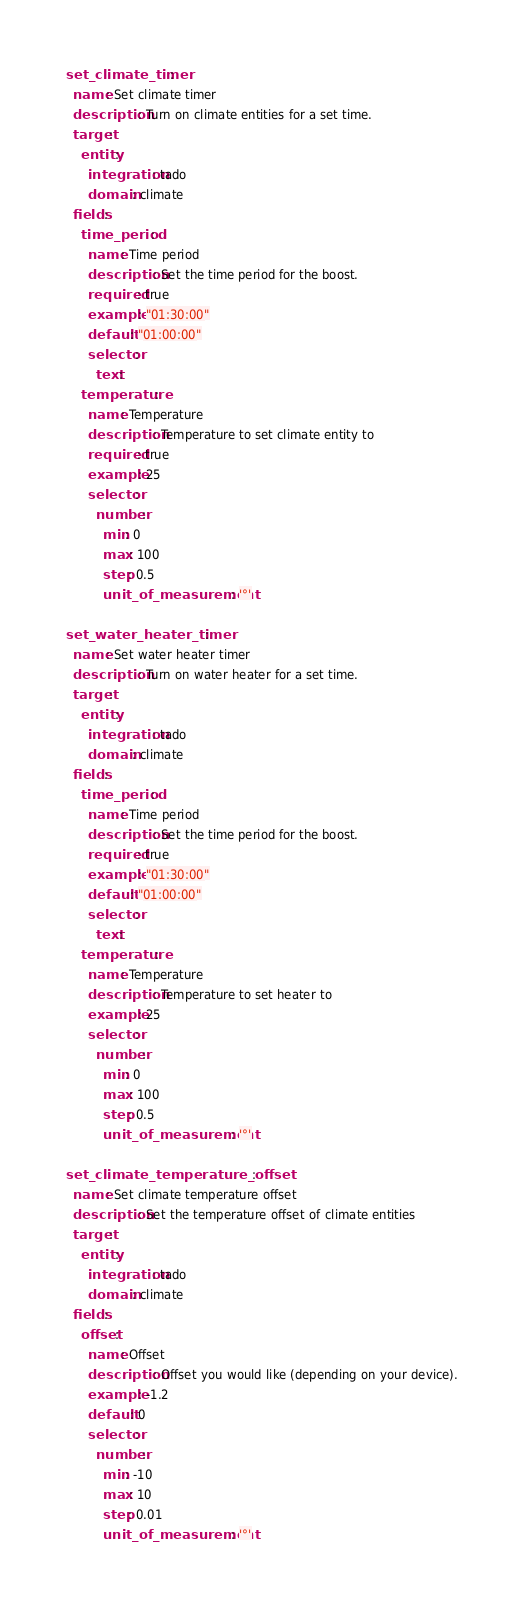<code> <loc_0><loc_0><loc_500><loc_500><_YAML_>set_climate_timer:
  name: Set climate timer
  description: Turn on climate entities for a set time.
  target:
    entity:
      integration: tado
      domain: climate
  fields:
    time_period:
      name: Time period
      description: Set the time period for the boost.
      required: true
      example: "01:30:00"
      default: "01:00:00"
      selector:
        text:
    temperature:
      name: Temperature
      description: Temperature to set climate entity to
      required: true
      example: 25
      selector:
        number:
          min: 0
          max: 100
          step: 0.5
          unit_of_measurement: '°'

set_water_heater_timer:
  name: Set water heater timer
  description: Turn on water heater for a set time.
  target:
    entity:
      integration: tado
      domain: climate
  fields:
    time_period:
      name: Time period
      description: Set the time period for the boost.
      required: true
      example: "01:30:00"
      default: "01:00:00"
      selector:
        text:
    temperature:
      name: Temperature
      description: Temperature to set heater to
      example: 25
      selector:
        number:
          min: 0
          max: 100
          step: 0.5
          unit_of_measurement: '°'

set_climate_temperature_offset:
  name: Set climate temperature offset
  description: Set the temperature offset of climate entities
  target:
    entity:
      integration: tado
      domain: climate
  fields:
    offset:
      name: Offset
      description: Offset you would like (depending on your device).
      example: -1.2
      default: 0
      selector:
        number:
          min: -10
          max: 10
          step: 0.01
          unit_of_measurement: '°'
</code> 